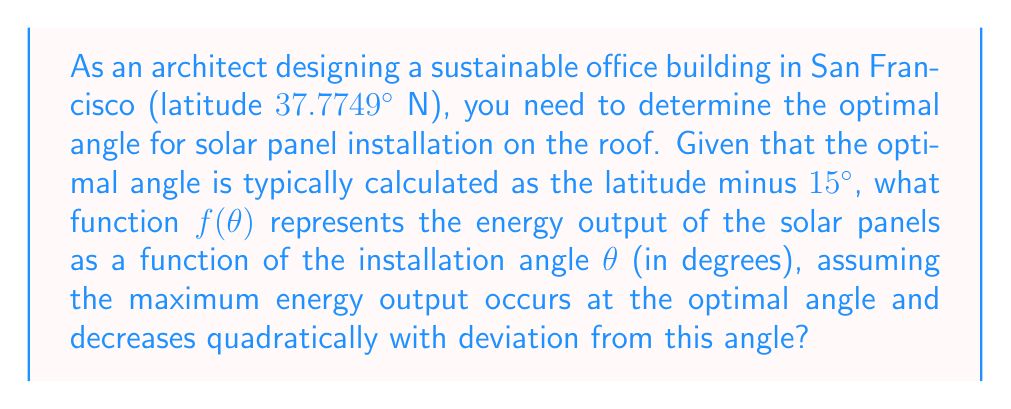Provide a solution to this math problem. To solve this problem, we'll follow these steps:

1. Calculate the optimal angle:
   Optimal angle = Latitude - 15°
   $\theta_{opt} = 37.7749° - 15° = 22.7749°$

2. Define a quadratic function that peaks at the optimal angle:
   The general form of a quadratic function is:
   $f(\theta) = a(\theta - h)^2 + k$
   Where $(h, k)$ is the vertex of the parabola.

3. In our case:
   $h = \theta_{opt} = 22.7749°$ (the angle at which maximum energy is produced)
   $k = 1$ (assuming the maximum energy output is normalized to 1)

4. Our function becomes:
   $f(\theta) = a(\theta - 22.7749)^2 + 1$

5. To determine $a$, we need an additional condition. Let's assume that at a 90° deviation from the optimal angle, the energy output is zero:
   $f(22.7749 + 90) = 0$
   $a(90)^2 + 1 = 0$
   $a = -\frac{1}{8100}$

6. Therefore, our final function is:
   $$f(\theta) = -\frac{1}{8100}(\theta - 22.7749)^2 + 1$$

This function represents the energy output of the solar panels, peaking at the optimal angle of 22.7749° and decreasing quadratically as the angle deviates from this optimum.
Answer: $f(\theta) = -\frac{1}{8100}(\theta - 22.7749)^2 + 1$ 